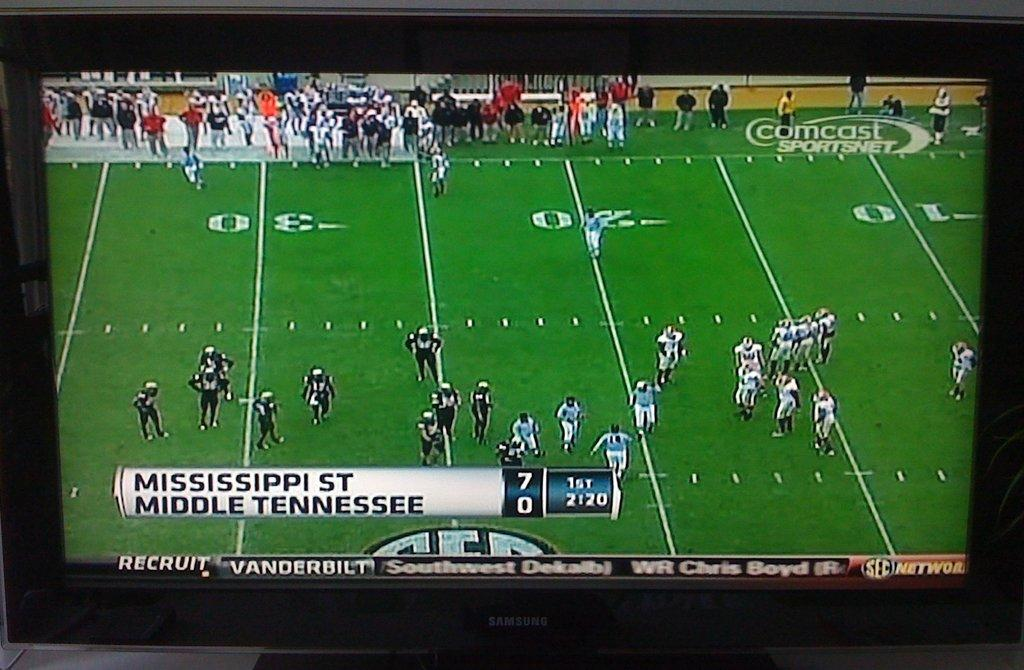<image>
Render a clear and concise summary of the photo. A television with a football game between MISSISSIPPI ST and MIDDLE TENNESSEE on Comcast. 